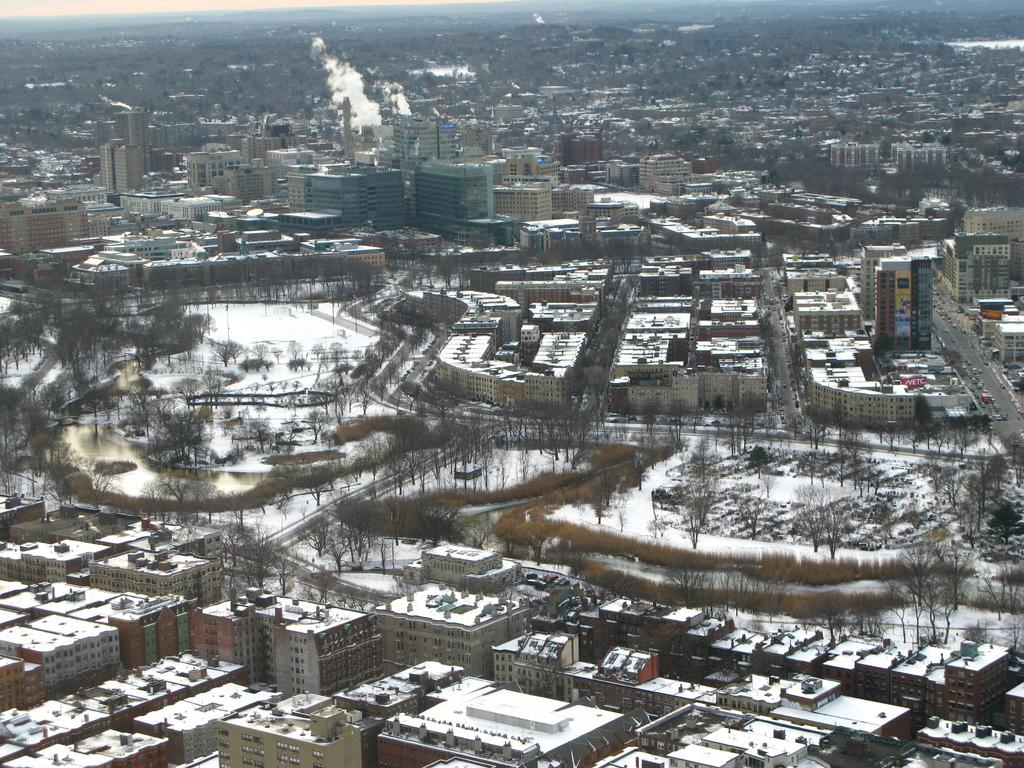What type of location is shown in the image? The image depicts a city. What weather condition is visible in the image? There is snow in the image. What structures can be seen in the city? There are buildings in the image. What type of vegetation is present in the city? Trees are present in the image. What can be used for transportation in the city? Roads and vehicles are visible in the image. What type of gate can be seen in the image? There is no gate present in the image. What authority figure is depicted in the image? There is no authority figure depicted in the image. 